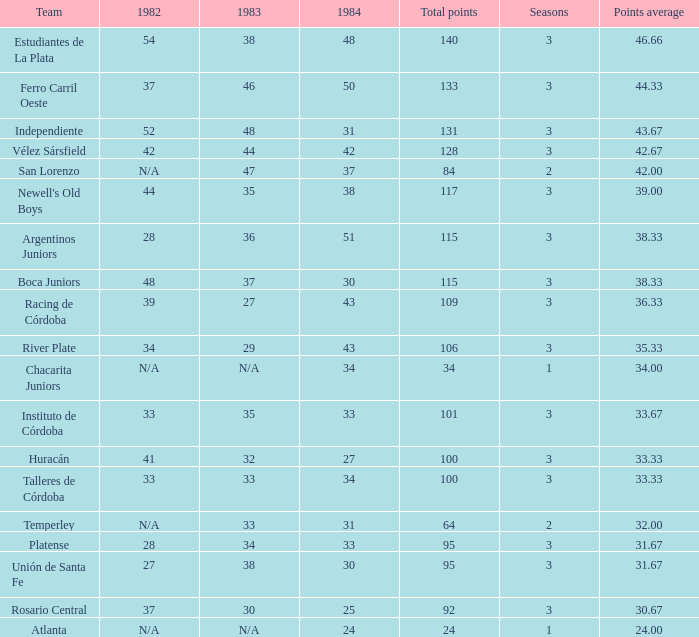What is the total for 1984 for the team with 100 points total and more than 3 seasons? None. 